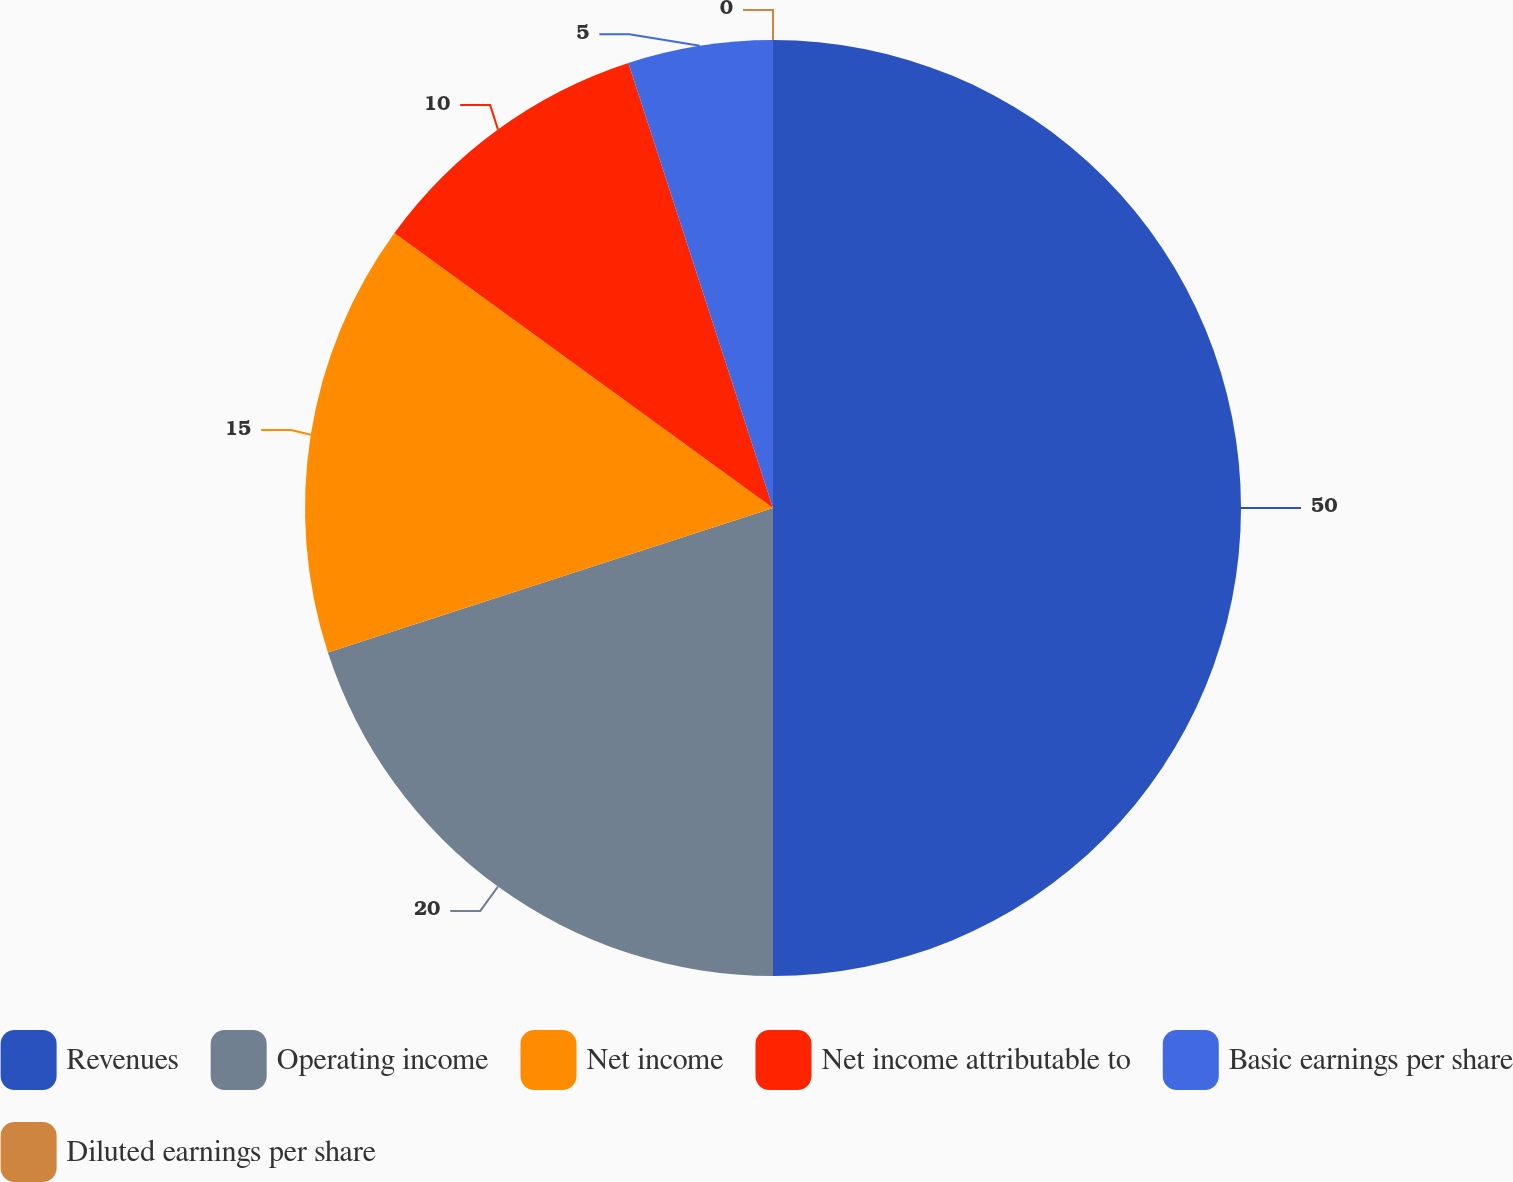Convert chart to OTSL. <chart><loc_0><loc_0><loc_500><loc_500><pie_chart><fcel>Revenues<fcel>Operating income<fcel>Net income<fcel>Net income attributable to<fcel>Basic earnings per share<fcel>Diluted earnings per share<nl><fcel>50.0%<fcel>20.0%<fcel>15.0%<fcel>10.0%<fcel>5.0%<fcel>0.0%<nl></chart> 